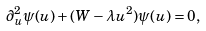Convert formula to latex. <formula><loc_0><loc_0><loc_500><loc_500>\partial _ { u } ^ { 2 } \psi ( u ) + ( W - \lambda u ^ { 2 } ) \psi ( u ) = 0 ,</formula> 